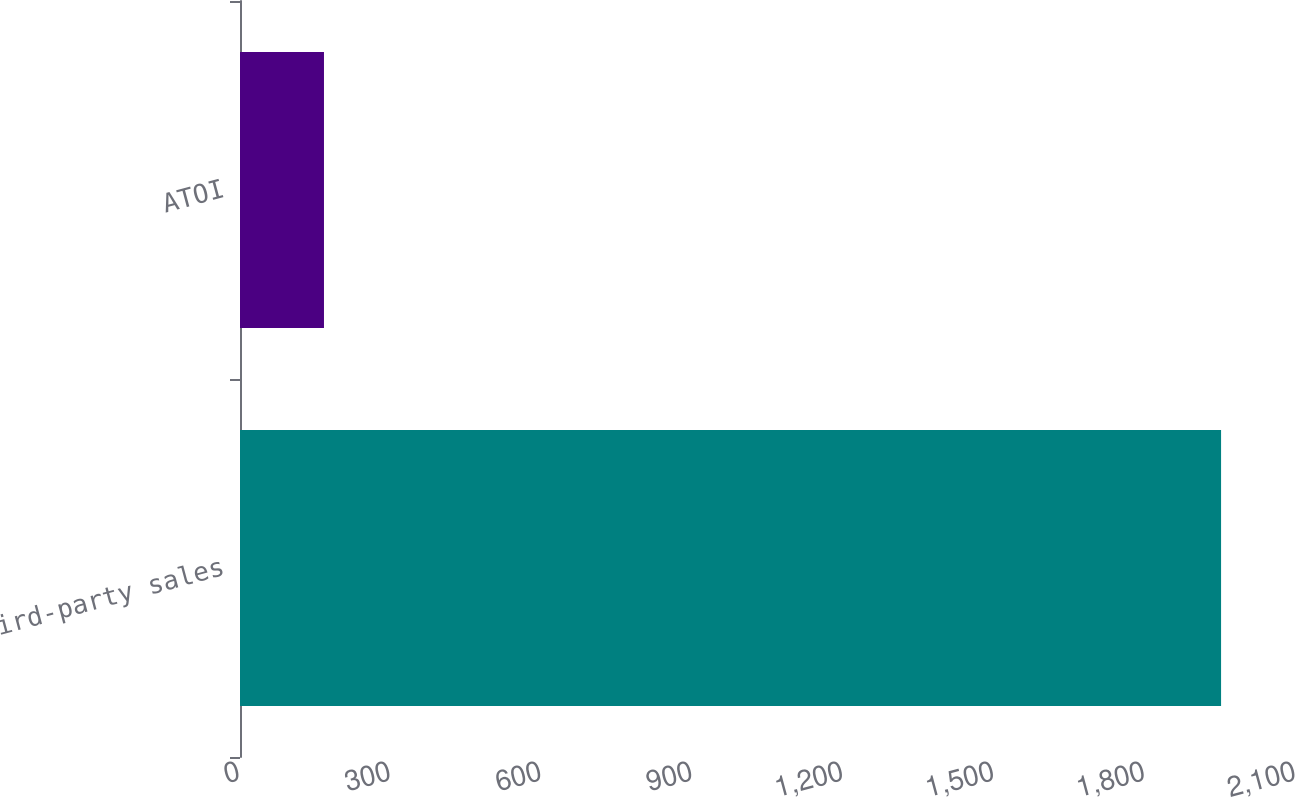Convert chart. <chart><loc_0><loc_0><loc_500><loc_500><bar_chart><fcel>Third-party sales<fcel>ATOI<nl><fcel>1951<fcel>167<nl></chart> 